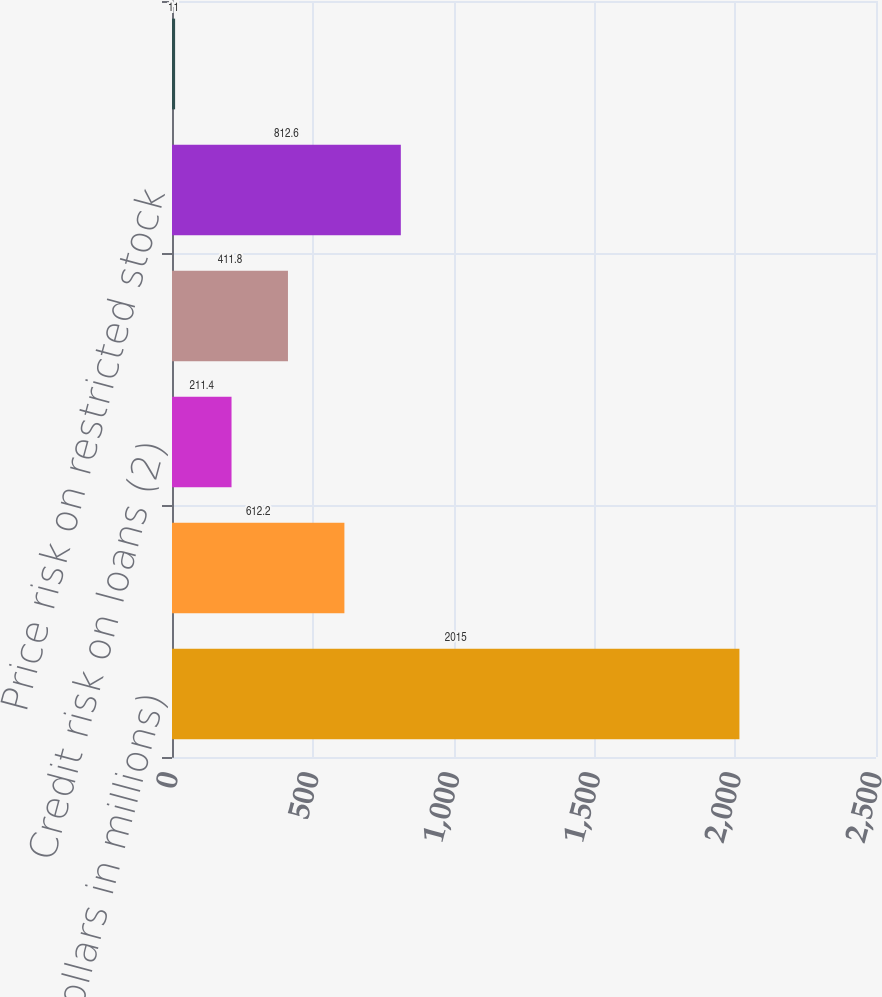Convert chart to OTSL. <chart><loc_0><loc_0><loc_500><loc_500><bar_chart><fcel>(Dollars in millions)<fcel>Interest rate risk on mortgage<fcel>Credit risk on loans (2)<fcel>Interest rate and foreign<fcel>Price risk on restricted stock<fcel>Other<nl><fcel>2015<fcel>612.2<fcel>211.4<fcel>411.8<fcel>812.6<fcel>11<nl></chart> 